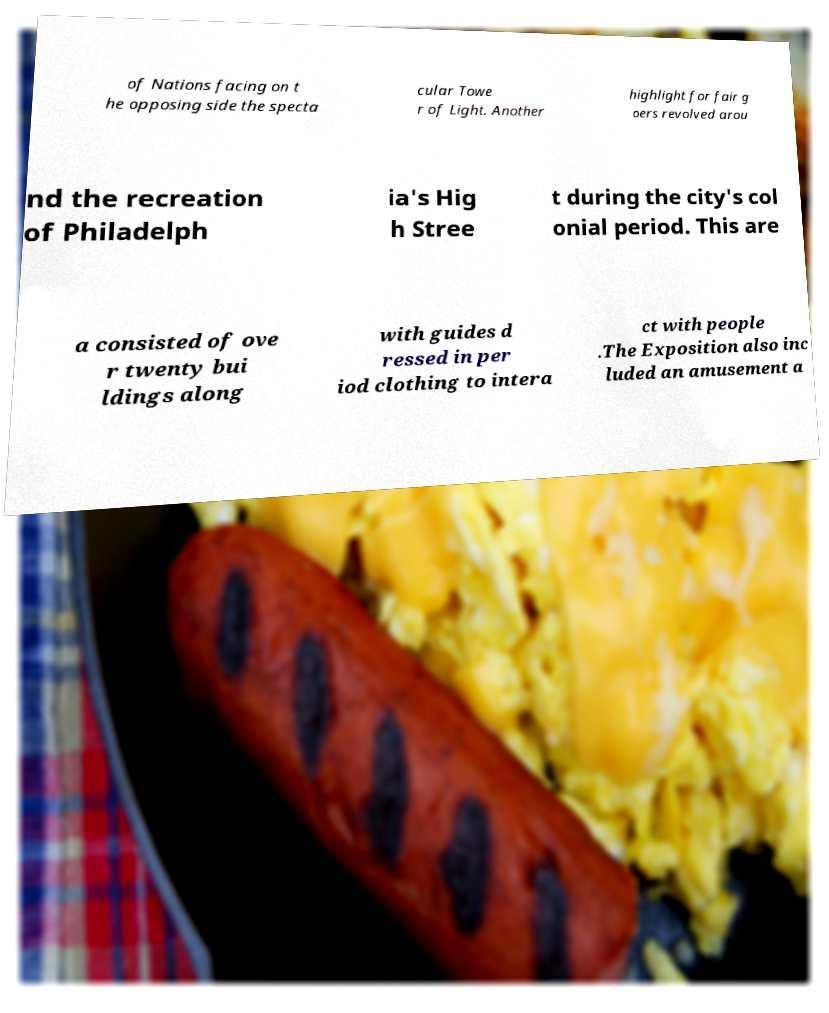Could you assist in decoding the text presented in this image and type it out clearly? of Nations facing on t he opposing side the specta cular Towe r of Light. Another highlight for fair g oers revolved arou nd the recreation of Philadelph ia's Hig h Stree t during the city's col onial period. This are a consisted of ove r twenty bui ldings along with guides d ressed in per iod clothing to intera ct with people .The Exposition also inc luded an amusement a 